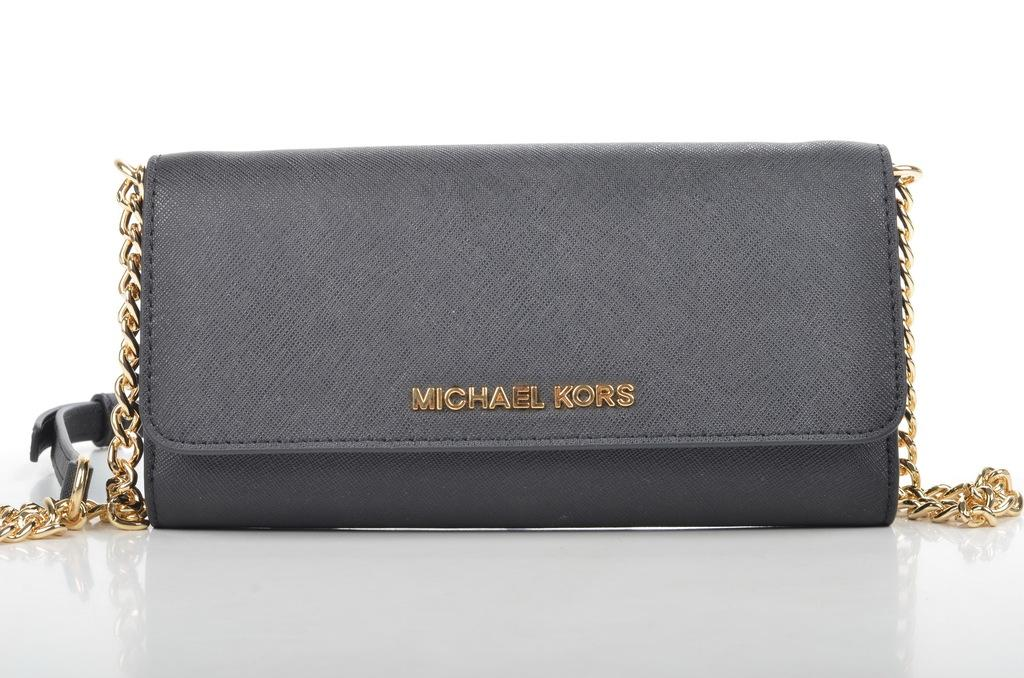What type of accessory is visible in the image? There is a handbag in the image. Can you identify the brand of the handbag? Yes, the handbag is labeled "Michael Kors." What type of net can be seen surrounding the volcano in the image? There is no net or volcano present in the image; it only features a handbag labeled "Michael Kors." 